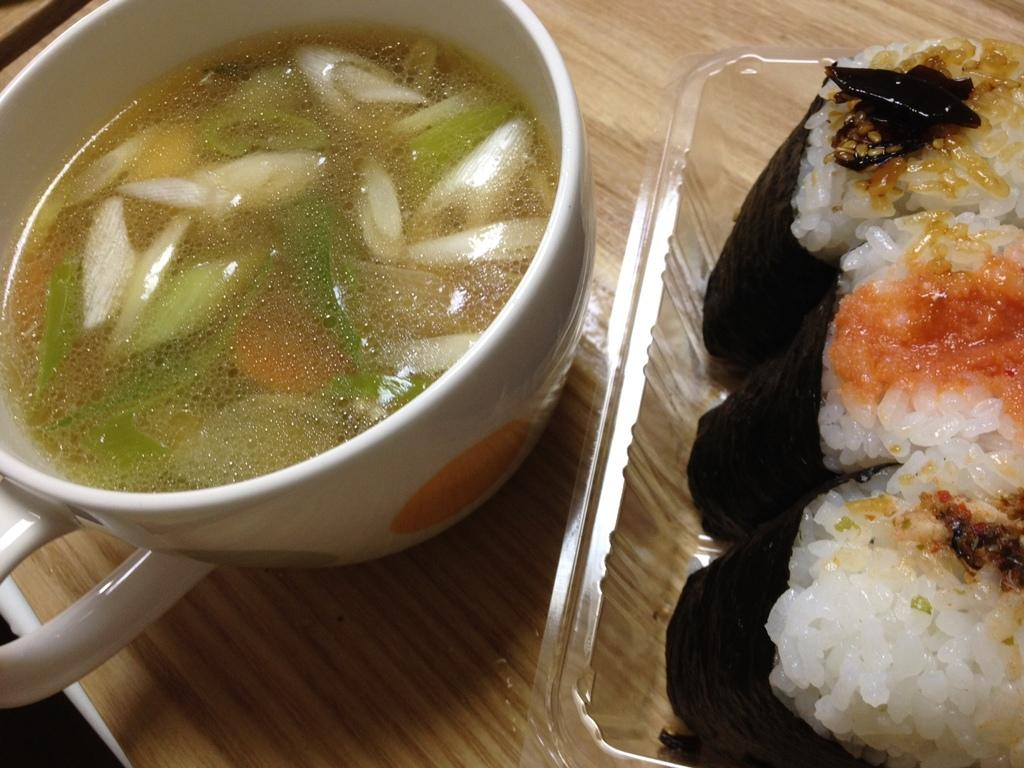What colors are present on the surface in the image? The surface in the image has a cream and brown color. What object can be seen on the surface? There is a plastic box on the surface. What is inside the plastic box? The plastic box contains food items. What type of dish is in the white-colored bowl on the surface? The bowl contains soup. What day of the week is depicted in the image? The image does not depict a day of the week; it shows a surface with a plastic box, food items, a white-colored bowl, and soup. 